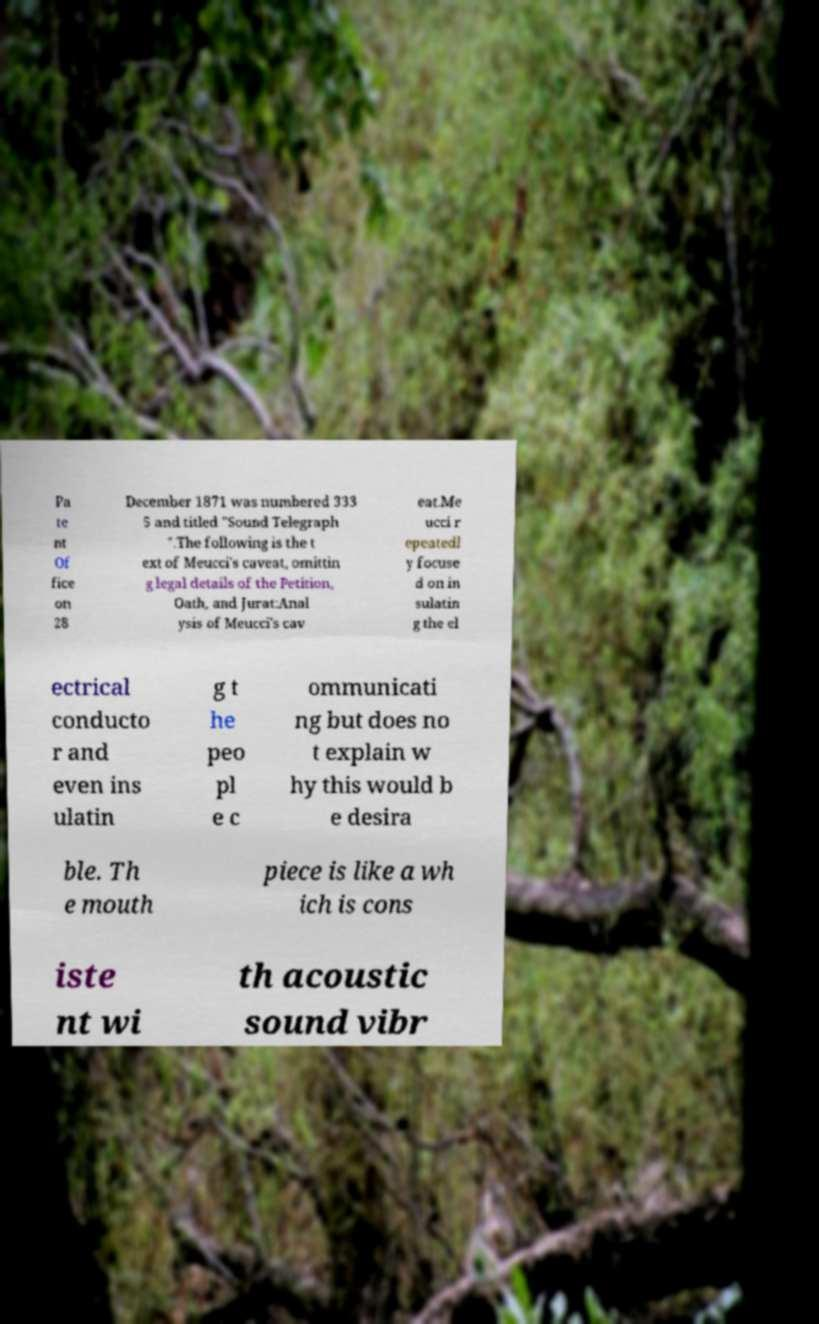I need the written content from this picture converted into text. Can you do that? Pa te nt Of fice on 28 December 1871 was numbered 333 5 and titled "Sound Telegraph ".The following is the t ext of Meucci's caveat, omittin g legal details of the Petition, Oath, and Jurat:Anal ysis of Meucci's cav eat.Me ucci r epeatedl y focuse d on in sulatin g the el ectrical conducto r and even ins ulatin g t he peo pl e c ommunicati ng but does no t explain w hy this would b e desira ble. Th e mouth piece is like a wh ich is cons iste nt wi th acoustic sound vibr 